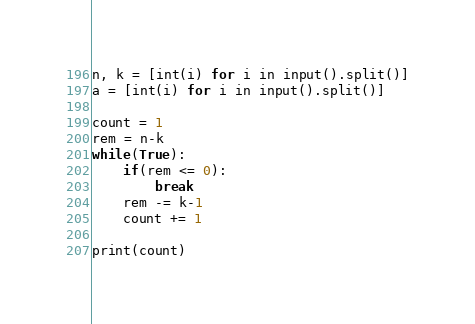Convert code to text. <code><loc_0><loc_0><loc_500><loc_500><_Python_>n, k = [int(i) for i in input().split()]
a = [int(i) for i in input().split()]

count = 1
rem = n-k
while(True):
    if(rem <= 0):
        break
    rem -= k-1
    count += 1
    
print(count)</code> 